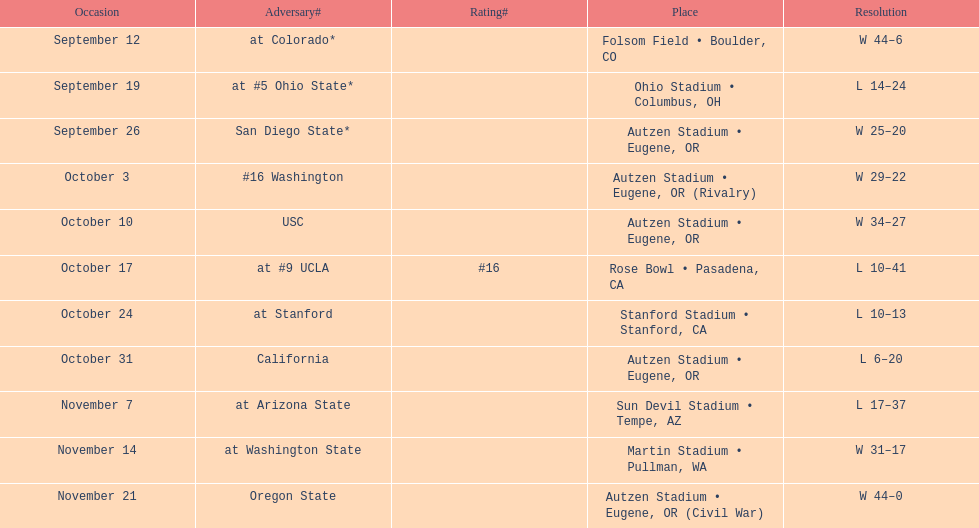Which bowl game did the university of oregon ducks football team play in during the 1987 season? Rose Bowl. 